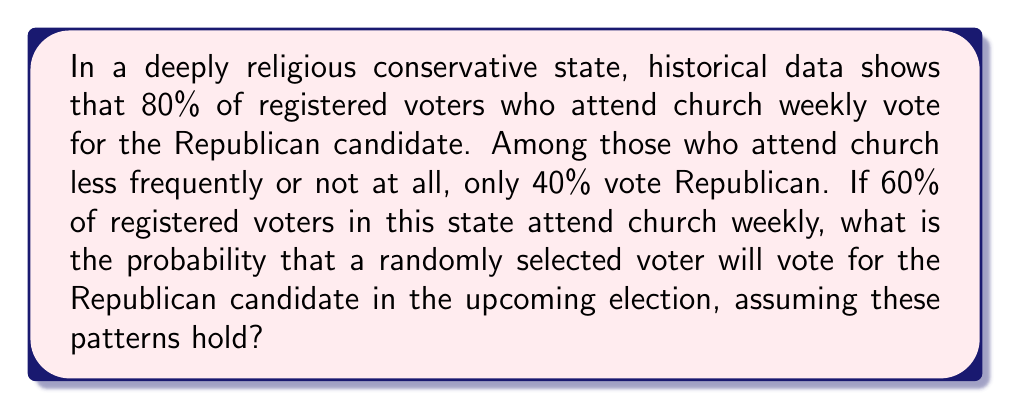Can you answer this question? To solve this problem, we'll use the law of total probability. Let's break it down step-by-step:

1) Let's define our events:
   R: Voter chooses Republican candidate
   W: Voter attends church weekly
   N: Voter does not attend church weekly

2) We're given the following probabilities:
   $P(R|W) = 0.80$ (probability of voting Republican given weekly church attendance)
   $P(R|N) = 0.40$ (probability of voting Republican given non-weekly church attendance)
   $P(W) = 0.60$ (probability of weekly church attendance)
   $P(N) = 1 - P(W) = 0.40$ (probability of non-weekly church attendance)

3) The law of total probability states:
   $P(R) = P(R|W) \cdot P(W) + P(R|N) \cdot P(N)$

4) Let's substitute our values:
   $P(R) = 0.80 \cdot 0.60 + 0.40 \cdot 0.40$

5) Now let's calculate:
   $P(R) = 0.48 + 0.16 = 0.64$

6) Convert to a percentage:
   $0.64 \cdot 100\% = 64\%$

Therefore, based on these voting patterns, there is a 64% probability that a randomly selected voter will vote for the Republican candidate.
Answer: 64% 